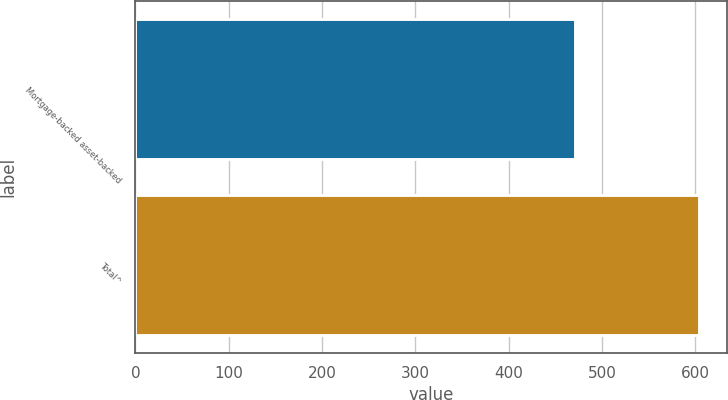<chart> <loc_0><loc_0><loc_500><loc_500><bar_chart><fcel>Mortgage-backed asset-backed<fcel>Total^<nl><fcel>471<fcel>604<nl></chart> 